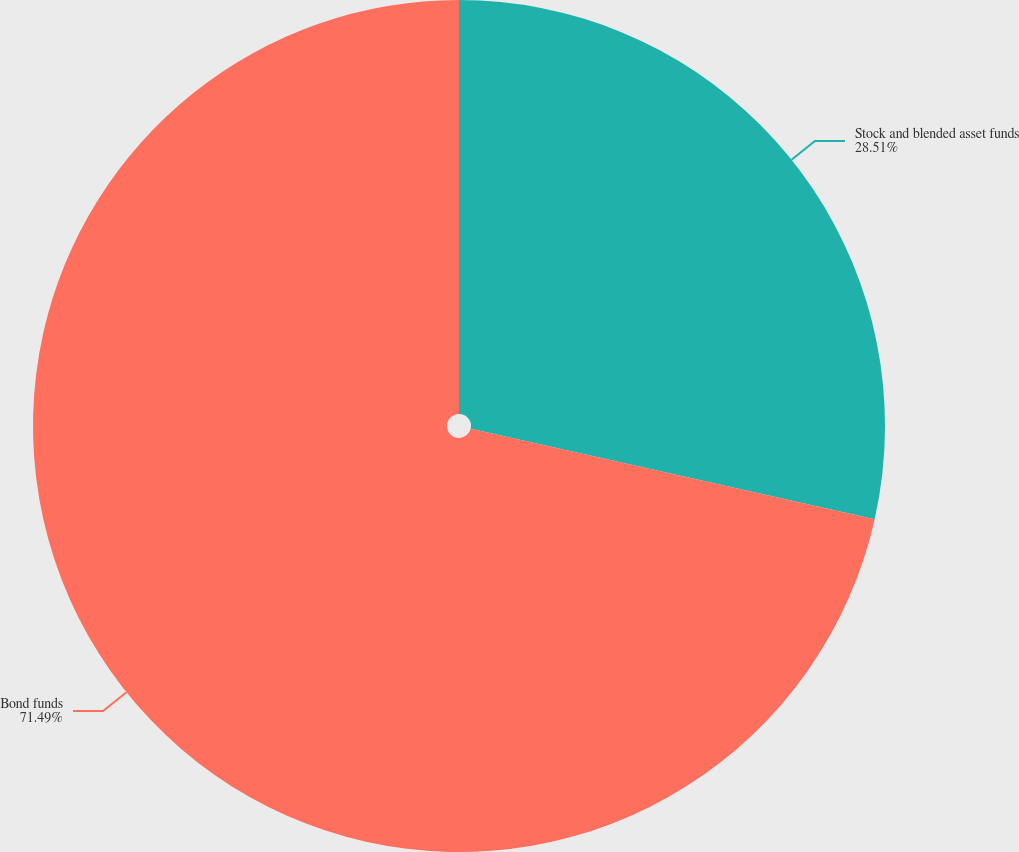<chart> <loc_0><loc_0><loc_500><loc_500><pie_chart><fcel>Stock and blended asset funds<fcel>Bond funds<nl><fcel>28.51%<fcel>71.49%<nl></chart> 